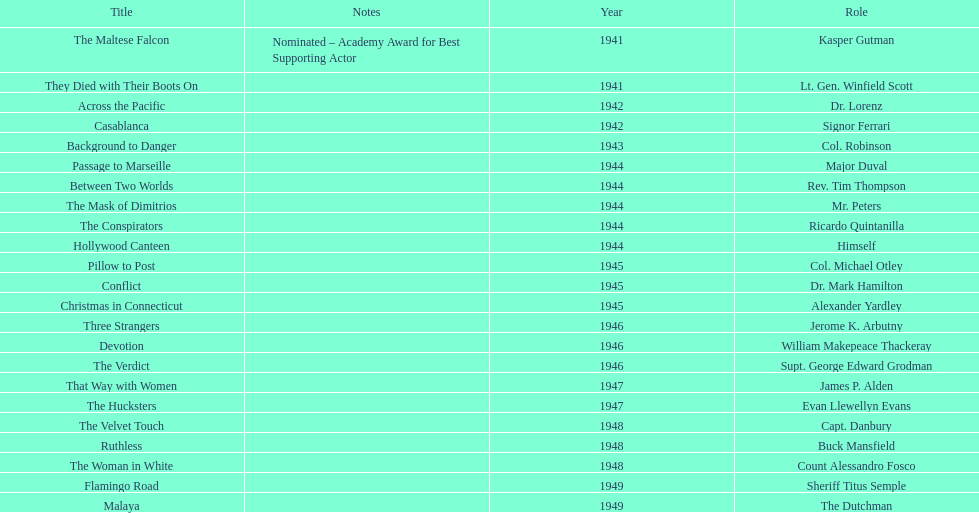How long did sydney greenstreet's acting career last? 9 years. 